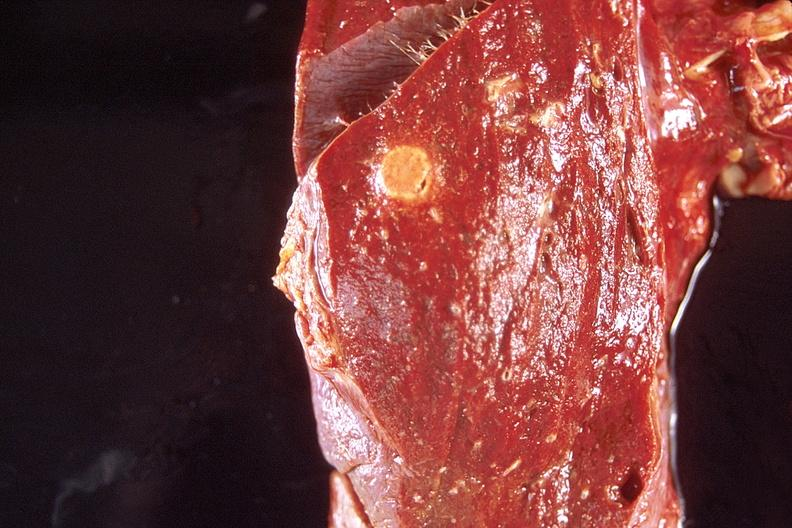does this image show lung, diffuse alveolar damage and abscess?
Answer the question using a single word or phrase. Yes 